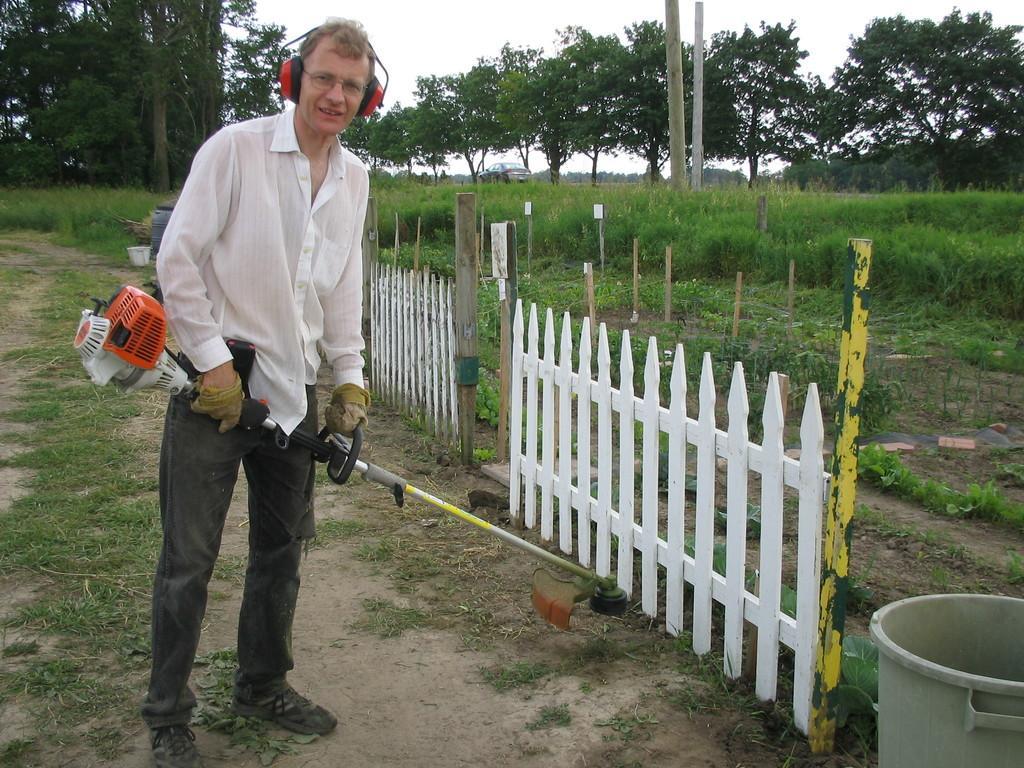Can you describe this image briefly? In this image, we can see some trees, plants and poles. There is a fence in the middle of the image. There is a person on the left side of the image standing and holding a machine with his hands. There is a tub in the bottom right of the image. At the top of the image, we can see the sky. 